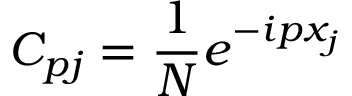<formula> <loc_0><loc_0><loc_500><loc_500>C _ { p j } = \frac { 1 } { N } e ^ { - i p x _ { j } }</formula> 